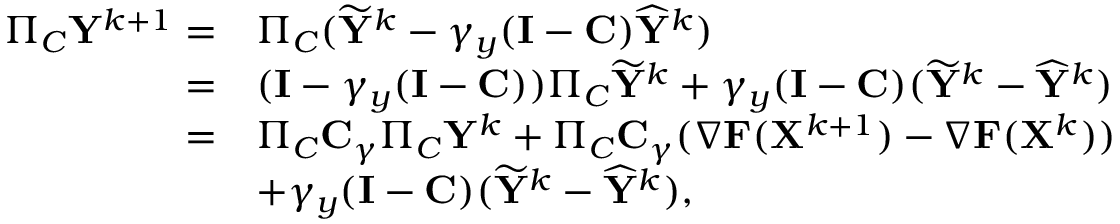Convert formula to latex. <formula><loc_0><loc_0><loc_500><loc_500>\begin{array} { r l } { \Pi _ { C } { Y } ^ { k + 1 } = } & { \Pi _ { C } ( \widetilde { Y } ^ { k } - \gamma _ { y } ( { I } - { C } ) \widehat { Y } ^ { k } ) } \\ { = } & { ( { I } - \gamma _ { y } ( { I } - { C } ) ) \Pi _ { C } \widetilde { Y } ^ { k } + \gamma _ { y } ( { I } - { C } ) ( \widetilde { Y } ^ { k } - \widehat { Y } ^ { k } ) } \\ { = } & { \Pi _ { C } { C } _ { \gamma } \Pi _ { C } { Y } ^ { k } + \Pi _ { C } { C } _ { \gamma } ( \nabla { F } ( { X } ^ { k + 1 } ) - \nabla { F } ( { X } ^ { k } ) ) } \\ & { + \gamma _ { y } ( { I } - { C } ) ( \widetilde { Y } ^ { k } - \widehat { Y } ^ { k } ) , } \end{array}</formula> 